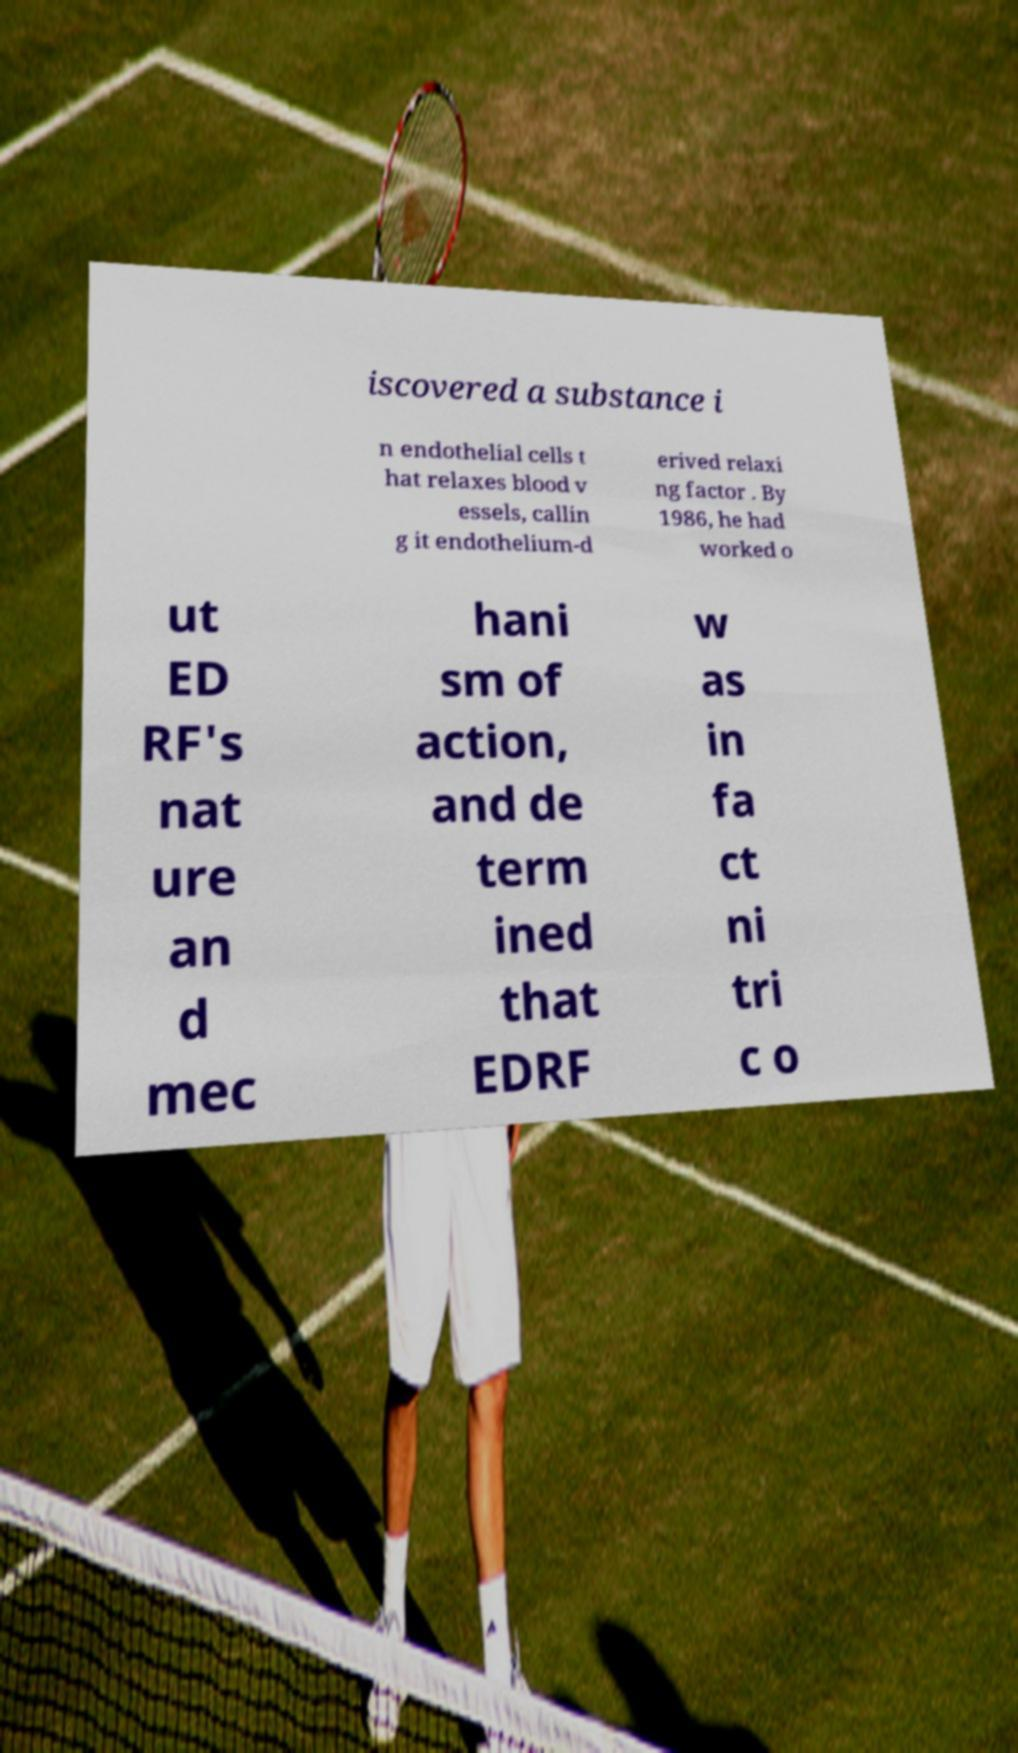I need the written content from this picture converted into text. Can you do that? iscovered a substance i n endothelial cells t hat relaxes blood v essels, callin g it endothelium-d erived relaxi ng factor . By 1986, he had worked o ut ED RF's nat ure an d mec hani sm of action, and de term ined that EDRF w as in fa ct ni tri c o 